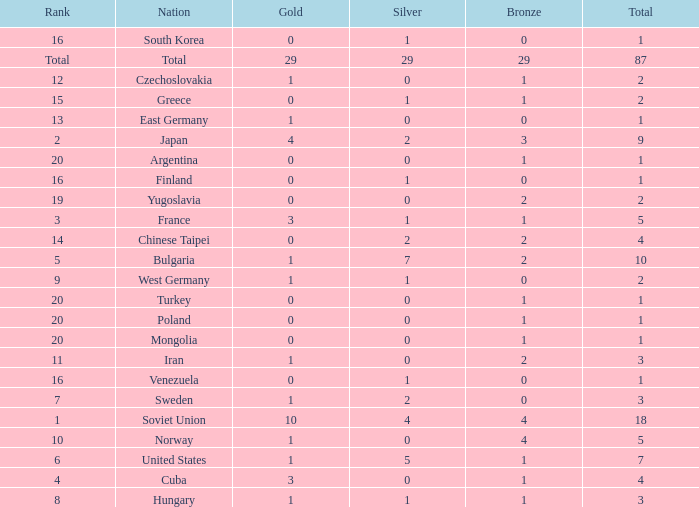What is the sum of gold medals for a rank of 14? 0.0. 